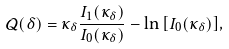<formula> <loc_0><loc_0><loc_500><loc_500>\mathcal { Q } ( \delta ) = \kappa _ { \delta } \frac { I _ { 1 } ( \kappa _ { \delta } ) } { I _ { 0 } ( \kappa _ { \delta } ) } - \ln { \left [ I _ { 0 } ( \kappa _ { \delta } ) \right ] } ,</formula> 